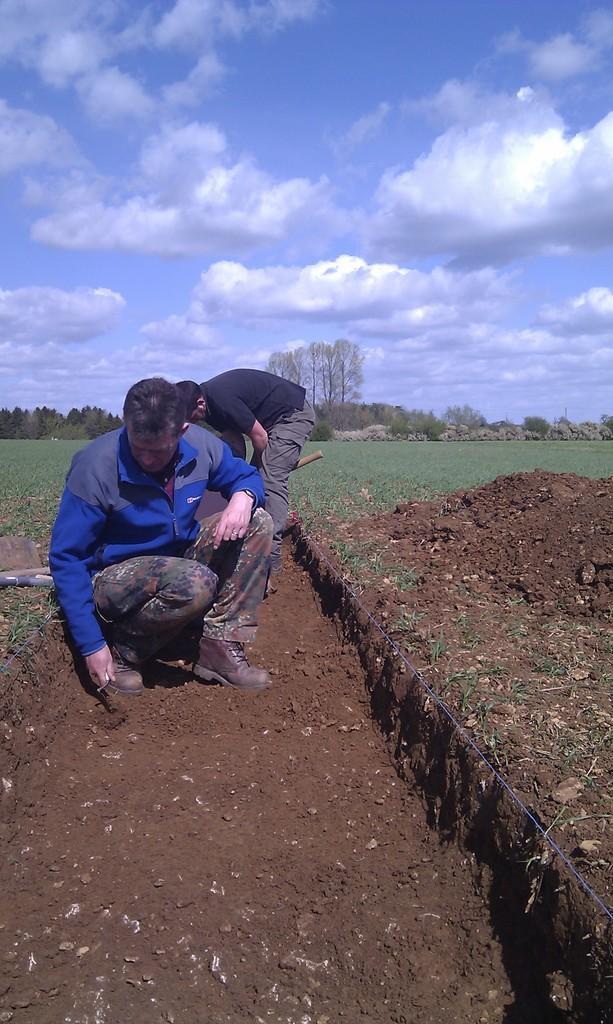In one or two sentences, can you explain what this image depicts? In this image there are two men. The man to the left is in squat position. Behind him there is another man bending forward. Behind them there's grass on the round. Beside them there is soil on the ground. In the background there are trees. At the top there is the sky. 